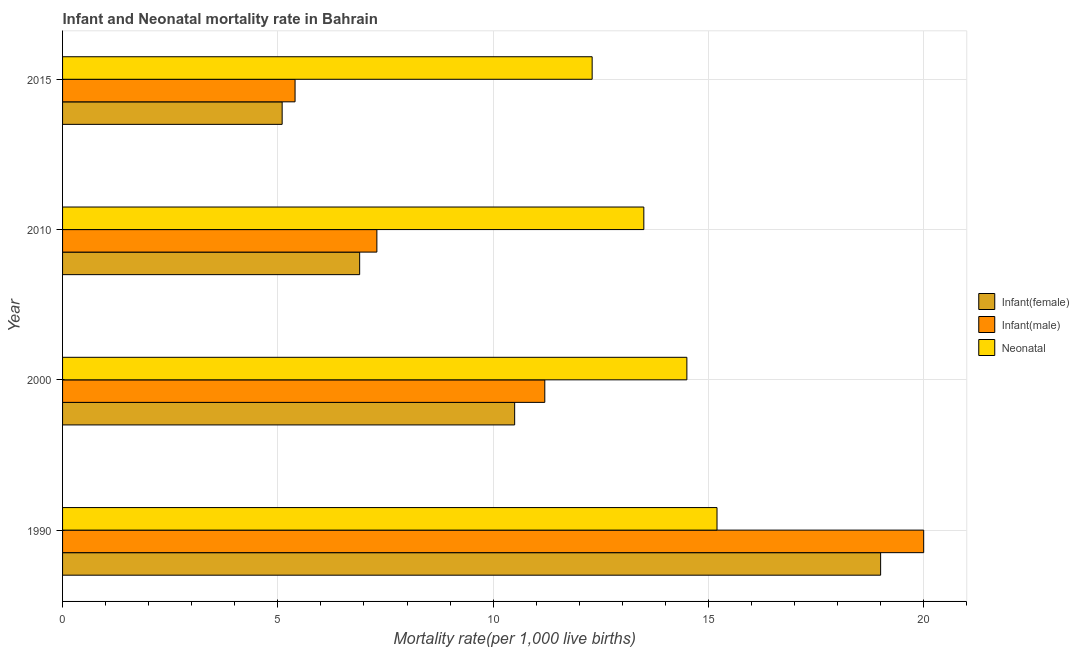How many groups of bars are there?
Your answer should be very brief. 4. Are the number of bars per tick equal to the number of legend labels?
Make the answer very short. Yes. In how many cases, is the number of bars for a given year not equal to the number of legend labels?
Provide a succinct answer. 0. Across all years, what is the maximum infant mortality rate(female)?
Keep it short and to the point. 19. In which year was the neonatal mortality rate maximum?
Your answer should be compact. 1990. In which year was the neonatal mortality rate minimum?
Your answer should be compact. 2015. What is the total infant mortality rate(male) in the graph?
Provide a short and direct response. 43.9. What is the difference between the neonatal mortality rate in 1990 and the infant mortality rate(male) in 2010?
Keep it short and to the point. 7.9. What is the average neonatal mortality rate per year?
Make the answer very short. 13.88. In the year 1990, what is the difference between the neonatal mortality rate and infant mortality rate(female)?
Offer a very short reply. -3.8. In how many years, is the infant mortality rate(female) greater than 17 ?
Make the answer very short. 1. What is the ratio of the infant mortality rate(male) in 2000 to that in 2010?
Ensure brevity in your answer.  1.53. Is the infant mortality rate(male) in 1990 less than that in 2015?
Give a very brief answer. No. What is the difference between the highest and the lowest infant mortality rate(female)?
Your answer should be very brief. 13.9. In how many years, is the neonatal mortality rate greater than the average neonatal mortality rate taken over all years?
Ensure brevity in your answer.  2. What does the 2nd bar from the top in 2000 represents?
Your answer should be very brief. Infant(male). What does the 2nd bar from the bottom in 2015 represents?
Provide a succinct answer. Infant(male). How many bars are there?
Your answer should be compact. 12. Are all the bars in the graph horizontal?
Provide a short and direct response. Yes. What is the difference between two consecutive major ticks on the X-axis?
Make the answer very short. 5. Are the values on the major ticks of X-axis written in scientific E-notation?
Ensure brevity in your answer.  No. Does the graph contain any zero values?
Offer a terse response. No. How many legend labels are there?
Ensure brevity in your answer.  3. What is the title of the graph?
Provide a short and direct response. Infant and Neonatal mortality rate in Bahrain. What is the label or title of the X-axis?
Make the answer very short. Mortality rate(per 1,0 live births). What is the Mortality rate(per 1,000 live births) in Neonatal  in 1990?
Offer a very short reply. 15.2. What is the Mortality rate(per 1,000 live births) in Neonatal  in 2000?
Your answer should be very brief. 14.5. What is the Mortality rate(per 1,000 live births) in Infant(female) in 2015?
Your answer should be very brief. 5.1. What is the Mortality rate(per 1,000 live births) of Infant(male) in 2015?
Give a very brief answer. 5.4. Across all years, what is the maximum Mortality rate(per 1,000 live births) of Infant(male)?
Offer a terse response. 20. Across all years, what is the minimum Mortality rate(per 1,000 live births) of Neonatal ?
Provide a short and direct response. 12.3. What is the total Mortality rate(per 1,000 live births) of Infant(female) in the graph?
Provide a short and direct response. 41.5. What is the total Mortality rate(per 1,000 live births) in Infant(male) in the graph?
Ensure brevity in your answer.  43.9. What is the total Mortality rate(per 1,000 live births) of Neonatal  in the graph?
Your answer should be compact. 55.5. What is the difference between the Mortality rate(per 1,000 live births) in Infant(male) in 1990 and that in 2000?
Your answer should be very brief. 8.8. What is the difference between the Mortality rate(per 1,000 live births) in Infant(female) in 1990 and that in 2010?
Provide a succinct answer. 12.1. What is the difference between the Mortality rate(per 1,000 live births) of Infant(male) in 1990 and that in 2010?
Provide a succinct answer. 12.7. What is the difference between the Mortality rate(per 1,000 live births) in Infant(female) in 1990 and that in 2015?
Provide a short and direct response. 13.9. What is the difference between the Mortality rate(per 1,000 live births) of Infant(male) in 1990 and that in 2015?
Your answer should be very brief. 14.6. What is the difference between the Mortality rate(per 1,000 live births) in Neonatal  in 1990 and that in 2015?
Ensure brevity in your answer.  2.9. What is the difference between the Mortality rate(per 1,000 live births) of Infant(female) in 2000 and that in 2010?
Your answer should be compact. 3.6. What is the difference between the Mortality rate(per 1,000 live births) of Infant(male) in 2000 and that in 2010?
Ensure brevity in your answer.  3.9. What is the difference between the Mortality rate(per 1,000 live births) of Neonatal  in 2000 and that in 2010?
Offer a terse response. 1. What is the difference between the Mortality rate(per 1,000 live births) of Infant(female) in 2000 and that in 2015?
Make the answer very short. 5.4. What is the difference between the Mortality rate(per 1,000 live births) of Infant(male) in 2010 and that in 2015?
Your answer should be compact. 1.9. What is the difference between the Mortality rate(per 1,000 live births) in Neonatal  in 2010 and that in 2015?
Make the answer very short. 1.2. What is the difference between the Mortality rate(per 1,000 live births) of Infant(female) in 1990 and the Mortality rate(per 1,000 live births) of Infant(male) in 2000?
Keep it short and to the point. 7.8. What is the difference between the Mortality rate(per 1,000 live births) in Infant(male) in 1990 and the Mortality rate(per 1,000 live births) in Neonatal  in 2000?
Your answer should be compact. 5.5. What is the difference between the Mortality rate(per 1,000 live births) in Infant(female) in 1990 and the Mortality rate(per 1,000 live births) in Neonatal  in 2010?
Keep it short and to the point. 5.5. What is the difference between the Mortality rate(per 1,000 live births) of Infant(female) in 1990 and the Mortality rate(per 1,000 live births) of Infant(male) in 2015?
Offer a terse response. 13.6. What is the difference between the Mortality rate(per 1,000 live births) of Infant(male) in 1990 and the Mortality rate(per 1,000 live births) of Neonatal  in 2015?
Provide a succinct answer. 7.7. What is the difference between the Mortality rate(per 1,000 live births) in Infant(male) in 2000 and the Mortality rate(per 1,000 live births) in Neonatal  in 2010?
Provide a succinct answer. -2.3. What is the difference between the Mortality rate(per 1,000 live births) of Infant(female) in 2000 and the Mortality rate(per 1,000 live births) of Neonatal  in 2015?
Make the answer very short. -1.8. What is the difference between the Mortality rate(per 1,000 live births) in Infant(female) in 2010 and the Mortality rate(per 1,000 live births) in Neonatal  in 2015?
Offer a very short reply. -5.4. What is the difference between the Mortality rate(per 1,000 live births) of Infant(male) in 2010 and the Mortality rate(per 1,000 live births) of Neonatal  in 2015?
Provide a succinct answer. -5. What is the average Mortality rate(per 1,000 live births) in Infant(female) per year?
Offer a very short reply. 10.38. What is the average Mortality rate(per 1,000 live births) of Infant(male) per year?
Your answer should be very brief. 10.97. What is the average Mortality rate(per 1,000 live births) of Neonatal  per year?
Provide a succinct answer. 13.88. In the year 1990, what is the difference between the Mortality rate(per 1,000 live births) of Infant(male) and Mortality rate(per 1,000 live births) of Neonatal ?
Keep it short and to the point. 4.8. In the year 2000, what is the difference between the Mortality rate(per 1,000 live births) of Infant(female) and Mortality rate(per 1,000 live births) of Neonatal ?
Give a very brief answer. -4. In the year 2010, what is the difference between the Mortality rate(per 1,000 live births) of Infant(female) and Mortality rate(per 1,000 live births) of Neonatal ?
Make the answer very short. -6.6. In the year 2010, what is the difference between the Mortality rate(per 1,000 live births) in Infant(male) and Mortality rate(per 1,000 live births) in Neonatal ?
Your answer should be compact. -6.2. In the year 2015, what is the difference between the Mortality rate(per 1,000 live births) in Infant(female) and Mortality rate(per 1,000 live births) in Neonatal ?
Make the answer very short. -7.2. What is the ratio of the Mortality rate(per 1,000 live births) of Infant(female) in 1990 to that in 2000?
Offer a terse response. 1.81. What is the ratio of the Mortality rate(per 1,000 live births) in Infant(male) in 1990 to that in 2000?
Provide a short and direct response. 1.79. What is the ratio of the Mortality rate(per 1,000 live births) in Neonatal  in 1990 to that in 2000?
Your answer should be very brief. 1.05. What is the ratio of the Mortality rate(per 1,000 live births) in Infant(female) in 1990 to that in 2010?
Provide a succinct answer. 2.75. What is the ratio of the Mortality rate(per 1,000 live births) of Infant(male) in 1990 to that in 2010?
Keep it short and to the point. 2.74. What is the ratio of the Mortality rate(per 1,000 live births) in Neonatal  in 1990 to that in 2010?
Keep it short and to the point. 1.13. What is the ratio of the Mortality rate(per 1,000 live births) of Infant(female) in 1990 to that in 2015?
Make the answer very short. 3.73. What is the ratio of the Mortality rate(per 1,000 live births) of Infant(male) in 1990 to that in 2015?
Your answer should be very brief. 3.7. What is the ratio of the Mortality rate(per 1,000 live births) in Neonatal  in 1990 to that in 2015?
Your response must be concise. 1.24. What is the ratio of the Mortality rate(per 1,000 live births) of Infant(female) in 2000 to that in 2010?
Your response must be concise. 1.52. What is the ratio of the Mortality rate(per 1,000 live births) in Infant(male) in 2000 to that in 2010?
Your response must be concise. 1.53. What is the ratio of the Mortality rate(per 1,000 live births) in Neonatal  in 2000 to that in 2010?
Provide a succinct answer. 1.07. What is the ratio of the Mortality rate(per 1,000 live births) in Infant(female) in 2000 to that in 2015?
Offer a terse response. 2.06. What is the ratio of the Mortality rate(per 1,000 live births) in Infant(male) in 2000 to that in 2015?
Provide a succinct answer. 2.07. What is the ratio of the Mortality rate(per 1,000 live births) of Neonatal  in 2000 to that in 2015?
Your answer should be very brief. 1.18. What is the ratio of the Mortality rate(per 1,000 live births) in Infant(female) in 2010 to that in 2015?
Keep it short and to the point. 1.35. What is the ratio of the Mortality rate(per 1,000 live births) in Infant(male) in 2010 to that in 2015?
Your response must be concise. 1.35. What is the ratio of the Mortality rate(per 1,000 live births) of Neonatal  in 2010 to that in 2015?
Offer a very short reply. 1.1. What is the difference between the highest and the second highest Mortality rate(per 1,000 live births) in Infant(female)?
Provide a short and direct response. 8.5. 